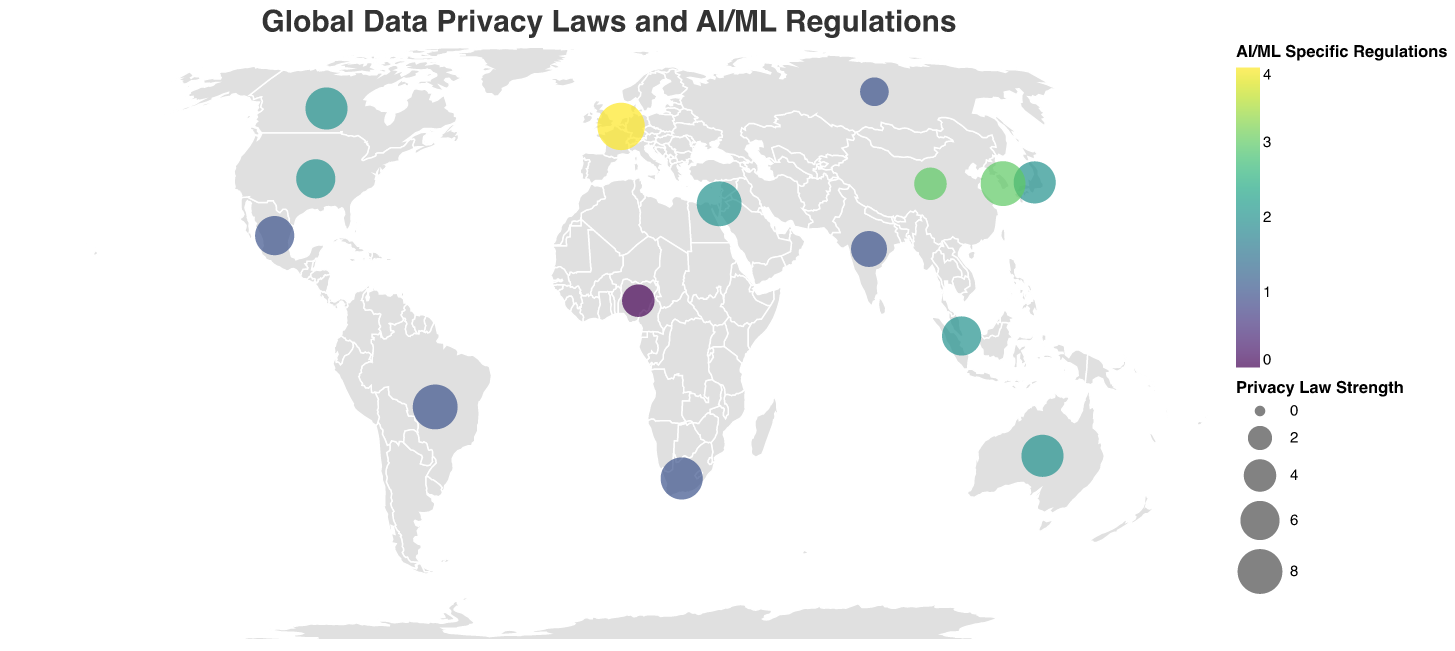What is the title of the figure? The title of the figure is positioned at the top and reads "Global Data Privacy Laws and AI/ML Regulations."
Answer: Global Data Privacy Laws and AI/ML Regulations Which country has the strongest data privacy law? The strongest data privacy law is indicated by the largest circle size. According to the visual, the European Union has the biggest circle, indicating the highest Privacy Law Strength of 9.
Answer: European Union How many countries have an AI/ML Specific Regulation Strength of 2? The legend shows different colors for AI/ML Specific Regulation Strength. By counting the number of circles with the corresponding color for '2' in the figure, we identify the countries. The countries are the United States, Japan, Canada, Australia, Israel, and Singapore, making it six countries.
Answer: 6 Which country has the earliest enacted privacy law and what year was it enacted? The enactment years vary and are placed within the data points. By locating the smallest year value, 1974, which corresponds to the United States, we can determine the earliest enacted privacy law.
Answer: United States, 1974 Which two countries have the same Privacy Law Strength and AI/ML Specific Regulations? By comparing circle sizes (indicator of Privacy Law Strength) and colors (indicator of AI/ML Specific Regulations), we find that Japan and Canada both have a Privacy Law Strength of 7 and AI/ML Specific Regulations of 2.
Answer: Japan and Canada Is there any country with no specific AI/ML regulations? A value of '0' in AI/ML regulations would be evident with a certain color. According to the visual, Nigeria is colored to indicate it has '0' specific AI/ML regulations.
Answer: Nigeria What is the average Privacy Law Strength of all the countries? Adding all the Privacy Law Strengths (6+9+4+7+8+5+7+7+3+8+6+6+7+4+8=97) and dividing by the number of countries (15) provides the average (97/15) ≈ 6.467.
Answer: 6.467 Identify the country with both the highest AI/ML Specific Regulations and the year it was enacted. The visual utilizes color to indicate AI/ML Specific Regulations strength. The darkest color represents '4,' which is unique to the European Union, and it was enacted in 2018.
Answer: European Union, 2018 